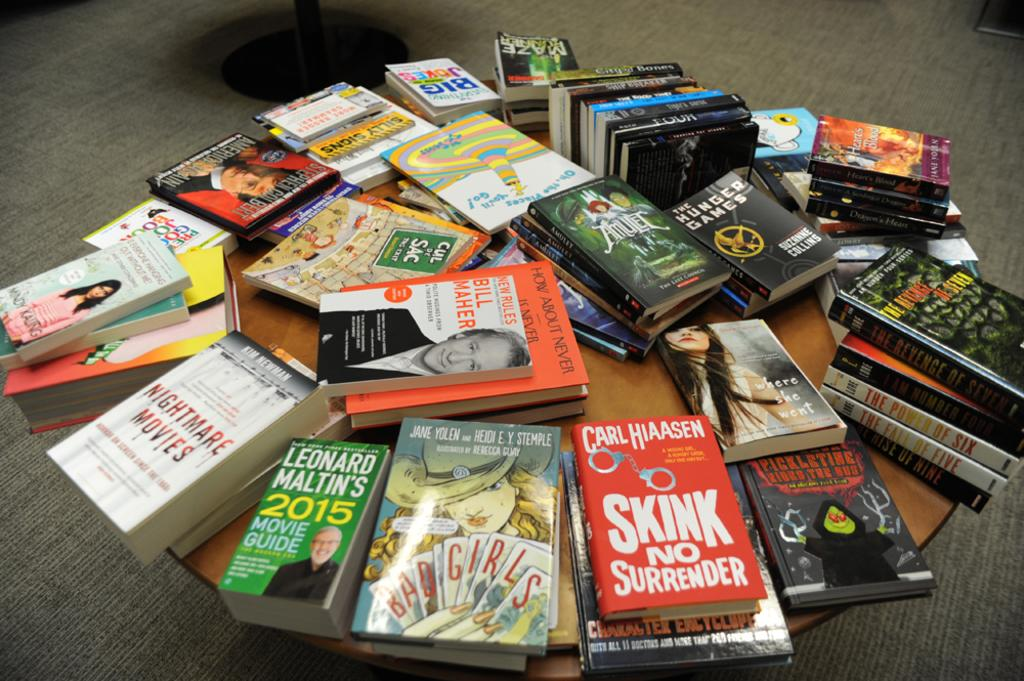<image>
Offer a succinct explanation of the picture presented. Red book called Skink No Surrender next to some other books on a table. 